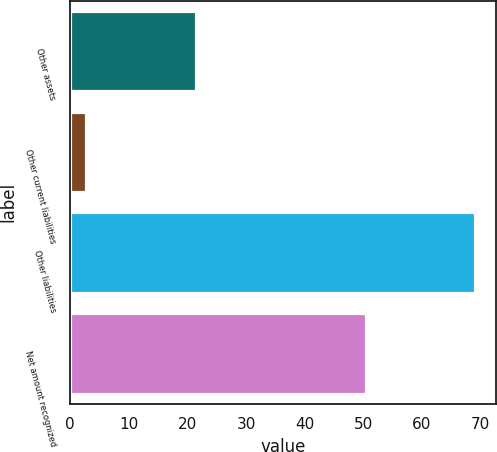Convert chart. <chart><loc_0><loc_0><loc_500><loc_500><bar_chart><fcel>Other assets<fcel>Other current liabilities<fcel>Other liabilities<fcel>Net amount recognized<nl><fcel>21.4<fcel>2.7<fcel>69.1<fcel>50.4<nl></chart> 